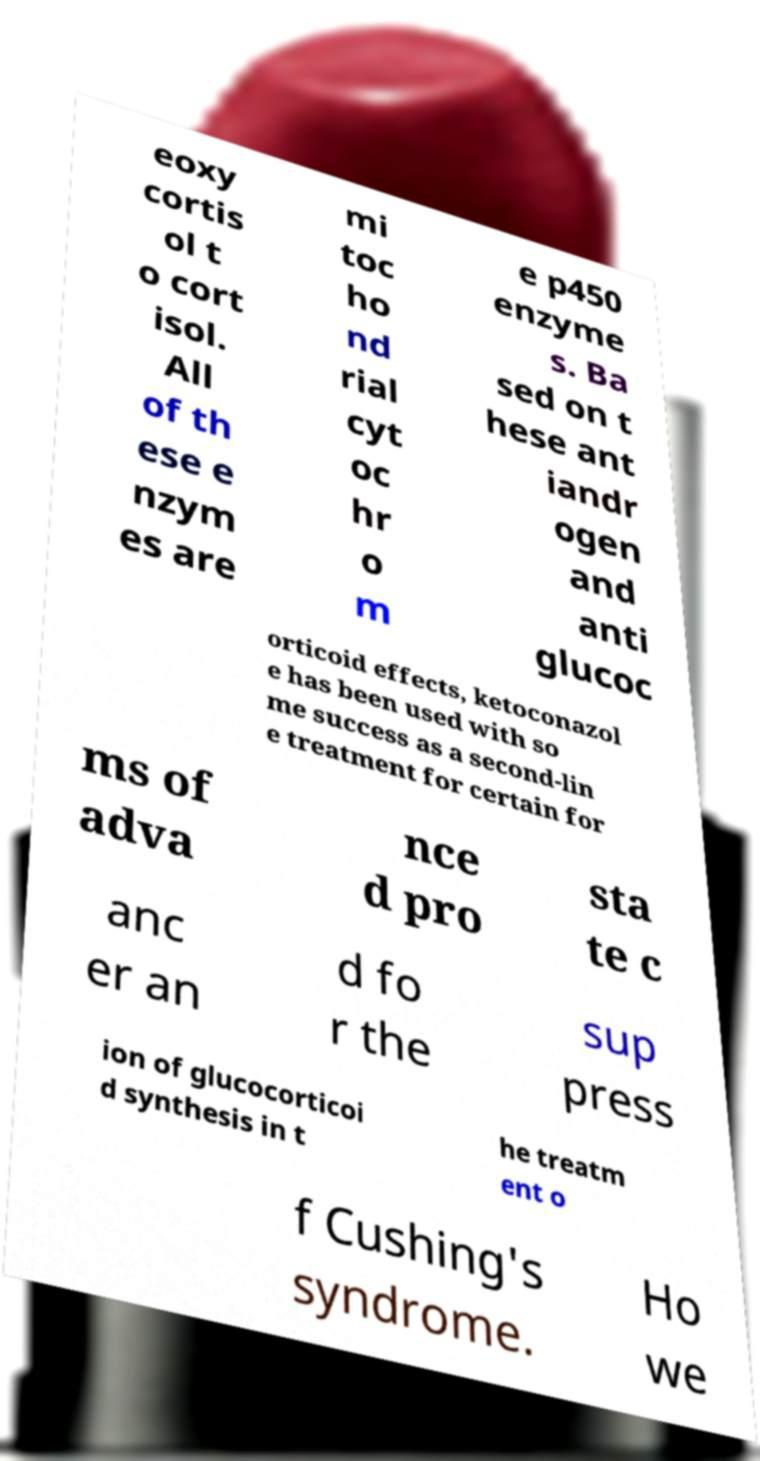There's text embedded in this image that I need extracted. Can you transcribe it verbatim? eoxy cortis ol t o cort isol. All of th ese e nzym es are mi toc ho nd rial cyt oc hr o m e p450 enzyme s. Ba sed on t hese ant iandr ogen and anti glucoc orticoid effects, ketoconazol e has been used with so me success as a second-lin e treatment for certain for ms of adva nce d pro sta te c anc er an d fo r the sup press ion of glucocorticoi d synthesis in t he treatm ent o f Cushing's syndrome. Ho we 